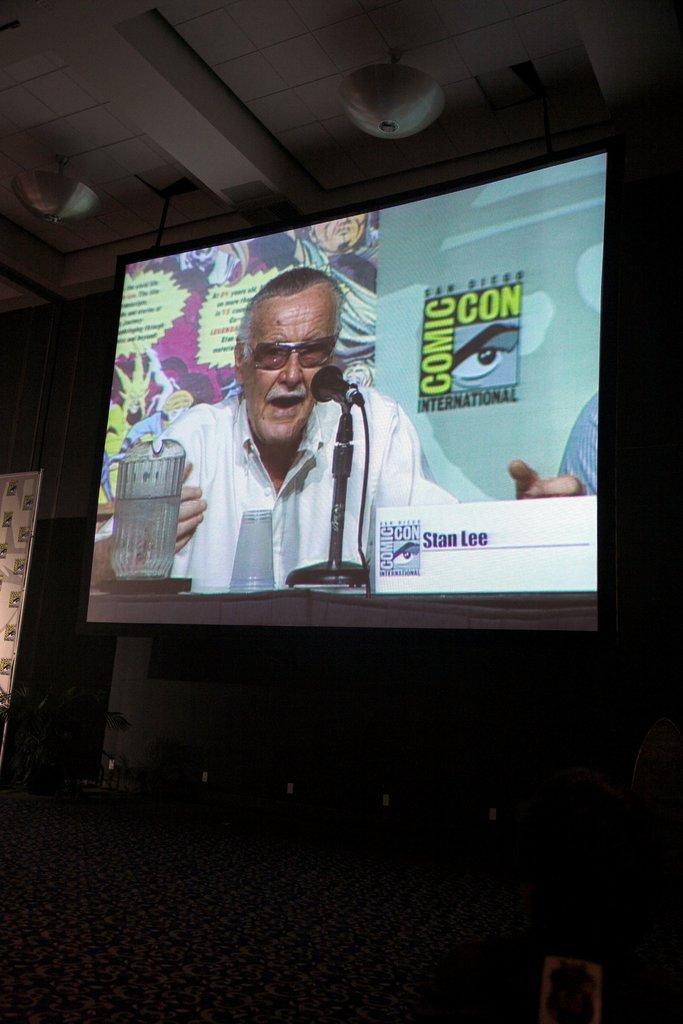What convention is shown on this television?
Keep it short and to the point. Comic con. Who is the man on the screen?
Keep it short and to the point. Stan lee. 